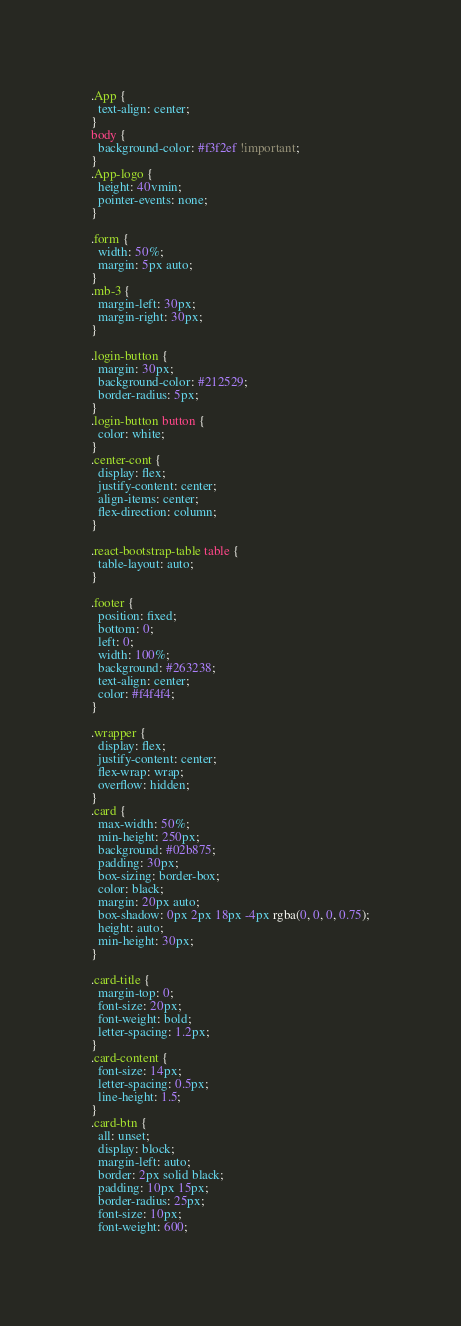<code> <loc_0><loc_0><loc_500><loc_500><_CSS_>.App {
  text-align: center;
}
body {
  background-color: #f3f2ef !important;
}
.App-logo {
  height: 40vmin;
  pointer-events: none;
}

.form {
  width: 50%;
  margin: 5px auto;
}
.mb-3 {
  margin-left: 30px;
  margin-right: 30px;
}

.login-button {
  margin: 30px;
  background-color: #212529;
  border-radius: 5px;
}
.login-button button {
  color: white;
}
.center-cont {
  display: flex;
  justify-content: center;
  align-items: center;
  flex-direction: column;
}

.react-bootstrap-table table {
  table-layout: auto;
}

.footer {
  position: fixed;
  bottom: 0;
  left: 0;
  width: 100%;
  background: #263238;
  text-align: center;
  color: #f4f4f4;
}

.wrapper {
  display: flex;
  justify-content: center;
  flex-wrap: wrap;
  overflow: hidden;
}
.card {
  max-width: 50%;
  min-height: 250px;
  background: #02b875;
  padding: 30px;
  box-sizing: border-box;
  color: black;
  margin: 20px auto;
  box-shadow: 0px 2px 18px -4px rgba(0, 0, 0, 0.75);
  height: auto;
  min-height: 30px;
}

.card-title {
  margin-top: 0;
  font-size: 20px;
  font-weight: bold;
  letter-spacing: 1.2px;
}
.card-content {
  font-size: 14px;
  letter-spacing: 0.5px;
  line-height: 1.5;
}
.card-btn {
  all: unset;
  display: block;
  margin-left: auto;
  border: 2px solid black;
  padding: 10px 15px;
  border-radius: 25px;
  font-size: 10px;
  font-weight: 600;</code> 